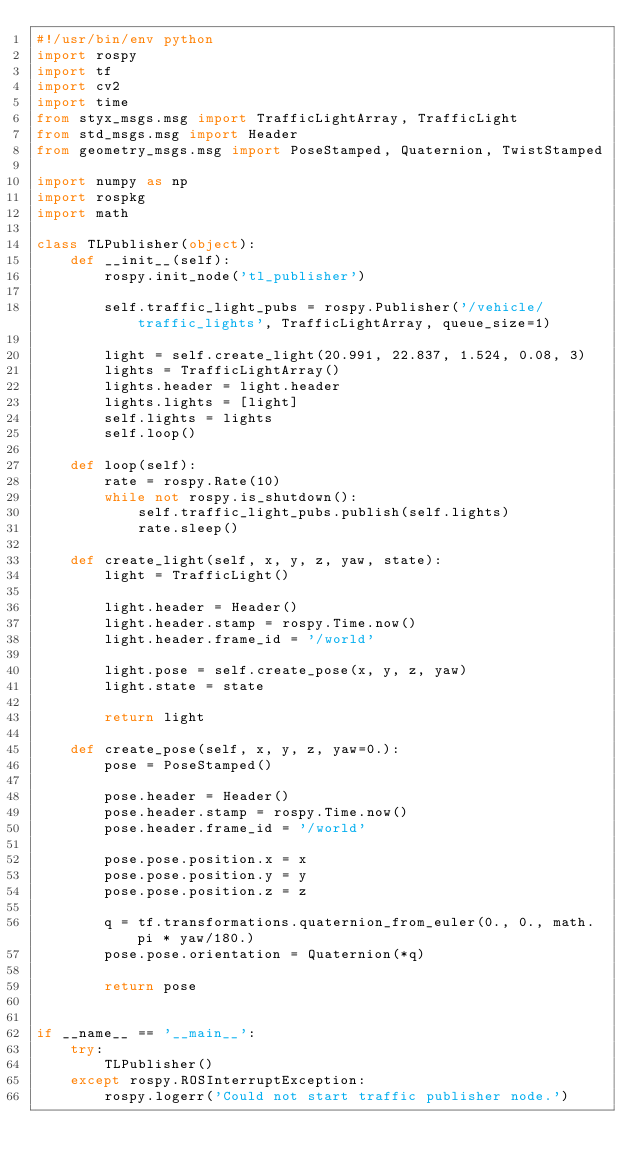Convert code to text. <code><loc_0><loc_0><loc_500><loc_500><_Python_>#!/usr/bin/env python
import rospy
import tf
import cv2
import time
from styx_msgs.msg import TrafficLightArray, TrafficLight
from std_msgs.msg import Header
from geometry_msgs.msg import PoseStamped, Quaternion, TwistStamped

import numpy as np
import rospkg
import math

class TLPublisher(object):
    def __init__(self):
        rospy.init_node('tl_publisher')

        self.traffic_light_pubs = rospy.Publisher('/vehicle/traffic_lights', TrafficLightArray, queue_size=1)

        light = self.create_light(20.991, 22.837, 1.524, 0.08, 3)
        lights = TrafficLightArray()
        lights.header = light.header
        lights.lights = [light]
        self.lights = lights
        self.loop()

    def loop(self):
        rate = rospy.Rate(10)
        while not rospy.is_shutdown():
            self.traffic_light_pubs.publish(self.lights)
            rate.sleep()

    def create_light(self, x, y, z, yaw, state):
        light = TrafficLight()

        light.header = Header()
        light.header.stamp = rospy.Time.now()
        light.header.frame_id = '/world'

        light.pose = self.create_pose(x, y, z, yaw)
        light.state = state

        return light

    def create_pose(self, x, y, z, yaw=0.):
        pose = PoseStamped()

        pose.header = Header()
        pose.header.stamp = rospy.Time.now()
        pose.header.frame_id = '/world'

        pose.pose.position.x = x
        pose.pose.position.y = y
        pose.pose.position.z = z

        q = tf.transformations.quaternion_from_euler(0., 0., math.pi * yaw/180.)
        pose.pose.orientation = Quaternion(*q)

        return pose


if __name__ == '__main__':
    try:
        TLPublisher()
    except rospy.ROSInterruptException:
        rospy.logerr('Could not start traffic publisher node.')
</code> 